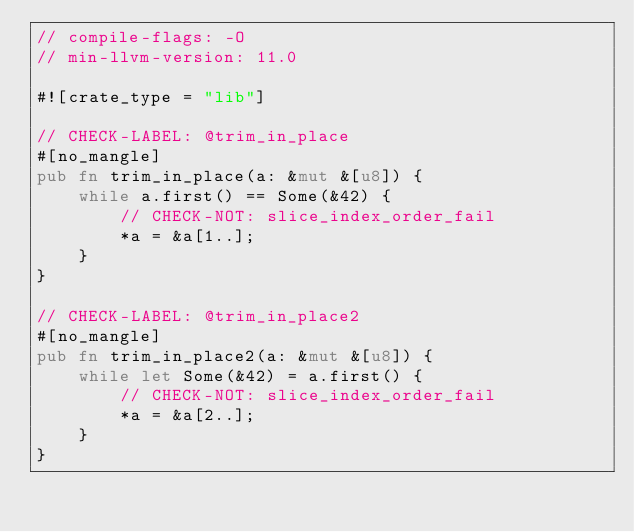Convert code to text. <code><loc_0><loc_0><loc_500><loc_500><_Rust_>// compile-flags: -O
// min-llvm-version: 11.0

#![crate_type = "lib"]

// CHECK-LABEL: @trim_in_place
#[no_mangle]
pub fn trim_in_place(a: &mut &[u8]) {
    while a.first() == Some(&42) {
        // CHECK-NOT: slice_index_order_fail
        *a = &a[1..];
    }
}

// CHECK-LABEL: @trim_in_place2
#[no_mangle]
pub fn trim_in_place2(a: &mut &[u8]) {
    while let Some(&42) = a.first() {
        // CHECK-NOT: slice_index_order_fail
        *a = &a[2..];
    }
}
</code> 